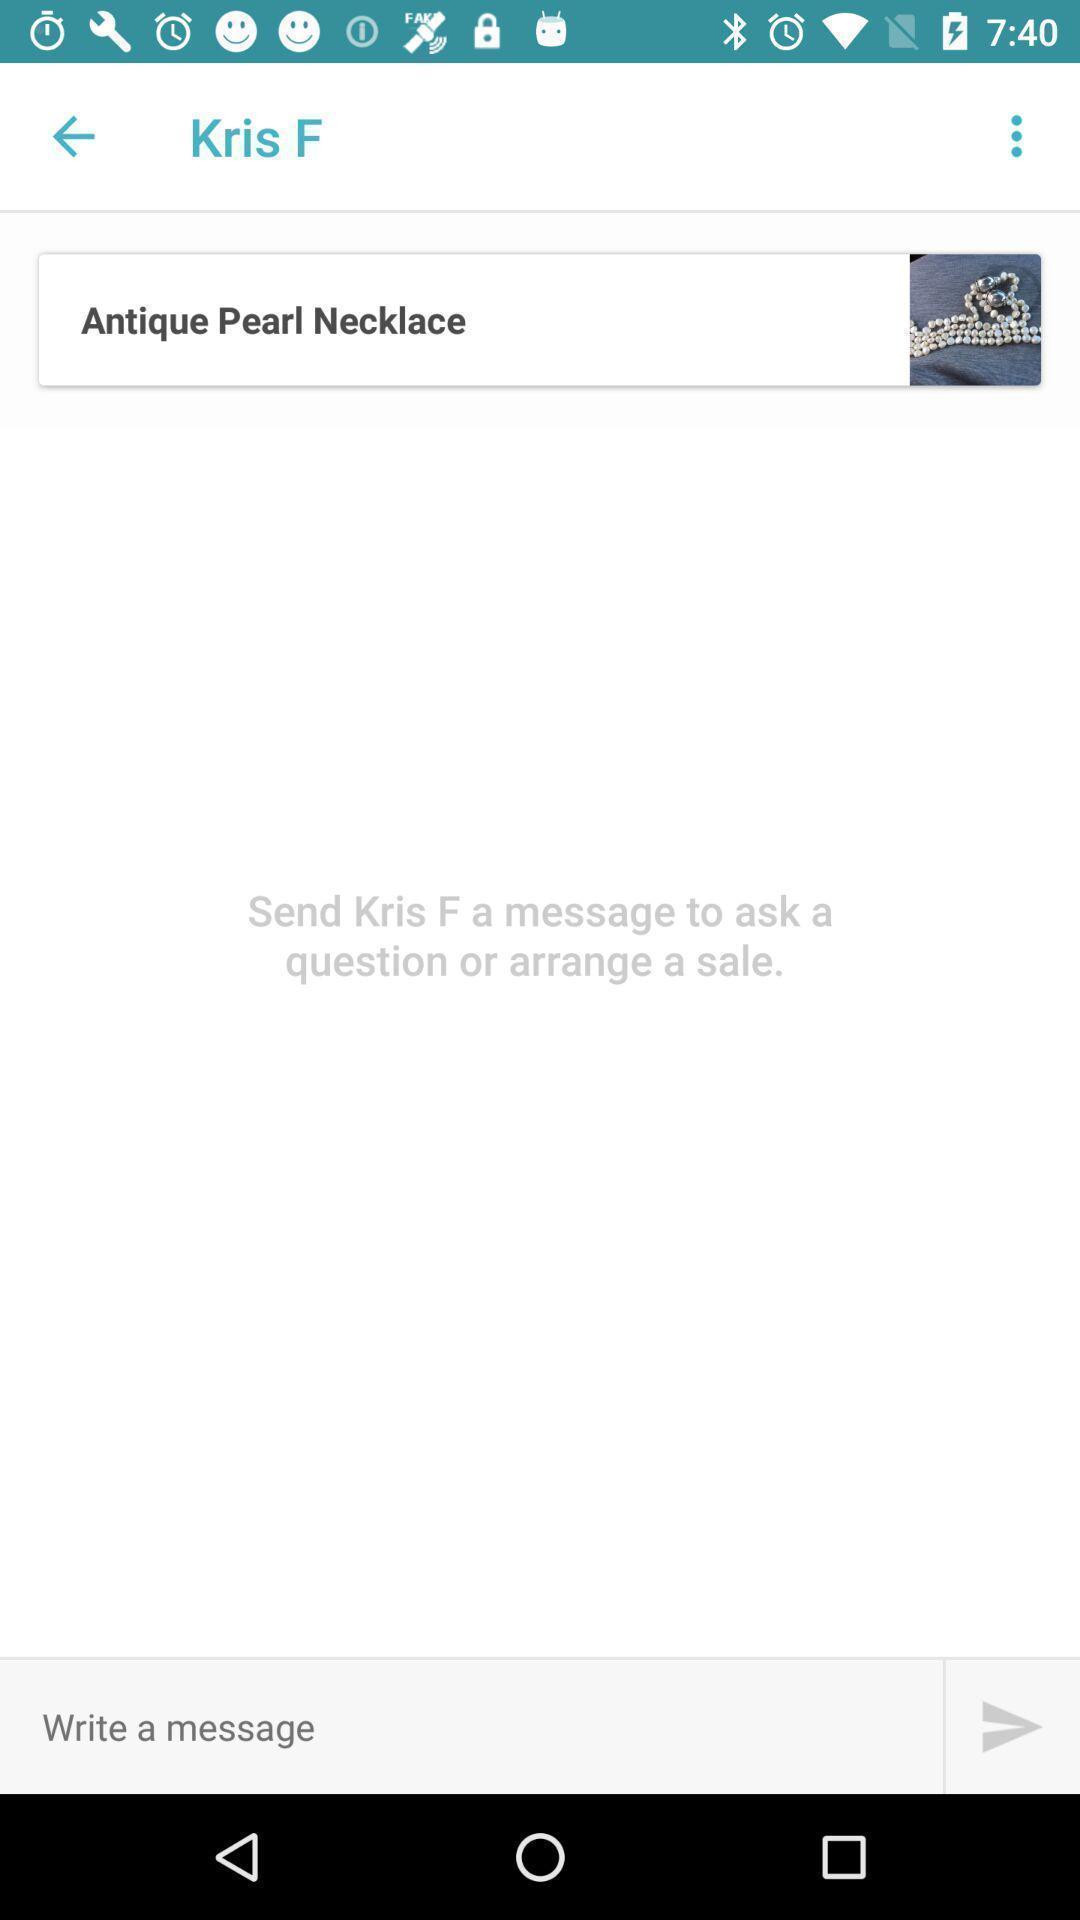Please provide a description for this image. Screen displaying a product image and user information. 